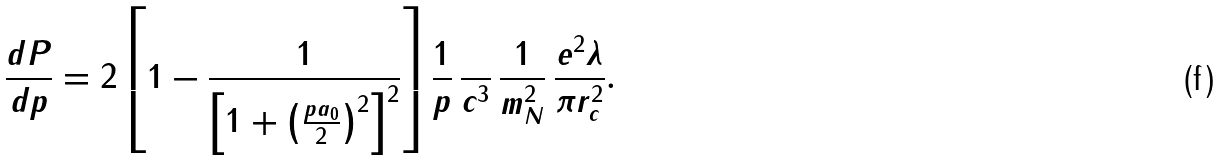Convert formula to latex. <formula><loc_0><loc_0><loc_500><loc_500>\frac { d P } { d p } = 2 \left [ 1 - \frac { 1 } { \left [ 1 + \left ( \frac { p a _ { 0 } } { 2 } \right ) ^ { 2 } \right ] ^ { 2 } } \right ] \frac { 1 } { p } \, \frac { } { c ^ { 3 } } \, \frac { 1 } { m _ { N } ^ { 2 } } \, \frac { e ^ { 2 } \lambda } { \pi r _ { c } ^ { 2 } } .</formula> 